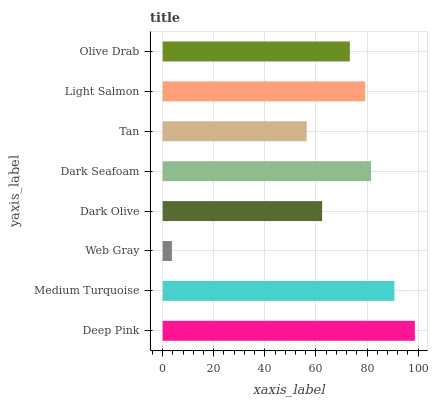Is Web Gray the minimum?
Answer yes or no. Yes. Is Deep Pink the maximum?
Answer yes or no. Yes. Is Medium Turquoise the minimum?
Answer yes or no. No. Is Medium Turquoise the maximum?
Answer yes or no. No. Is Deep Pink greater than Medium Turquoise?
Answer yes or no. Yes. Is Medium Turquoise less than Deep Pink?
Answer yes or no. Yes. Is Medium Turquoise greater than Deep Pink?
Answer yes or no. No. Is Deep Pink less than Medium Turquoise?
Answer yes or no. No. Is Light Salmon the high median?
Answer yes or no. Yes. Is Olive Drab the low median?
Answer yes or no. Yes. Is Dark Seafoam the high median?
Answer yes or no. No. Is Deep Pink the low median?
Answer yes or no. No. 